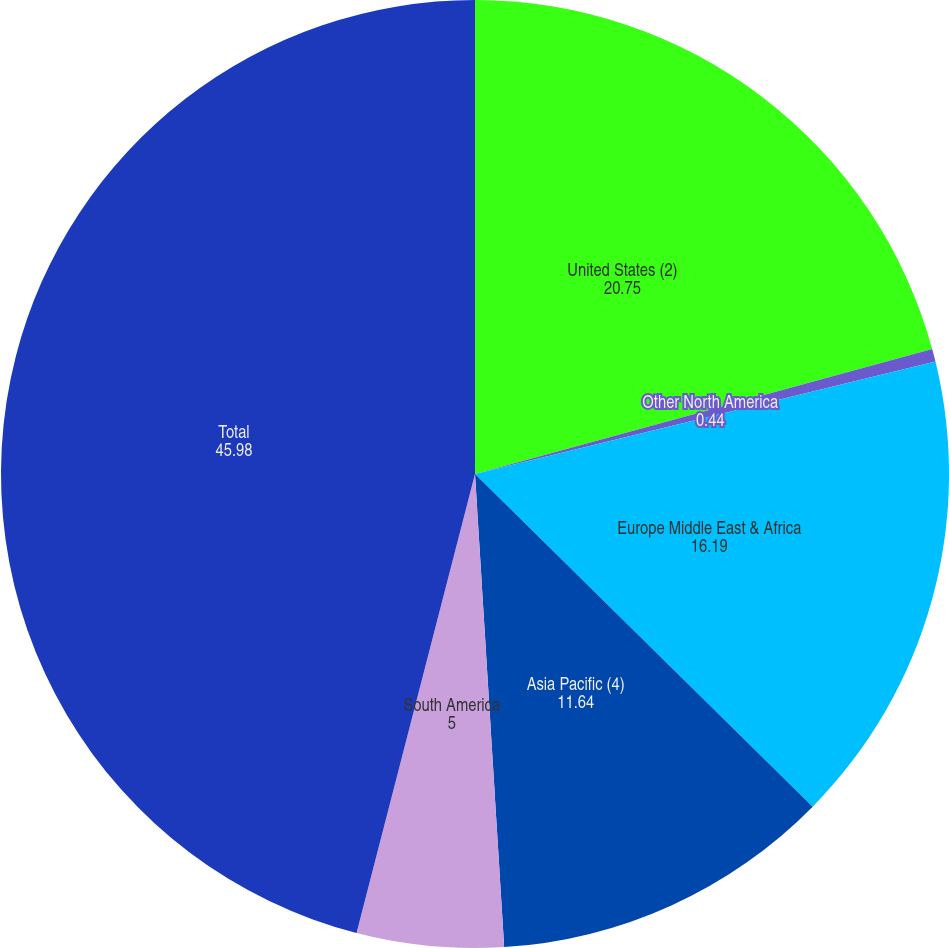<chart> <loc_0><loc_0><loc_500><loc_500><pie_chart><fcel>United States (2)<fcel>Other North America<fcel>Europe Middle East & Africa<fcel>Asia Pacific (4)<fcel>South America<fcel>Total<nl><fcel>20.75%<fcel>0.44%<fcel>16.19%<fcel>11.64%<fcel>5.0%<fcel>45.98%<nl></chart> 